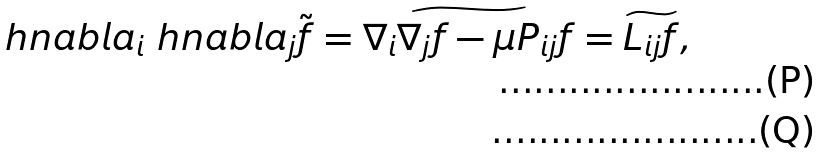Convert formula to latex. <formula><loc_0><loc_0><loc_500><loc_500>& \ h n a b l a _ { i } \ h n a b l a _ { j } \tilde { f } = \widetilde { \nabla _ { i } \nabla _ { j } f - \mu P _ { i j } f } = \widetilde { L _ { i j } f } , \\</formula> 